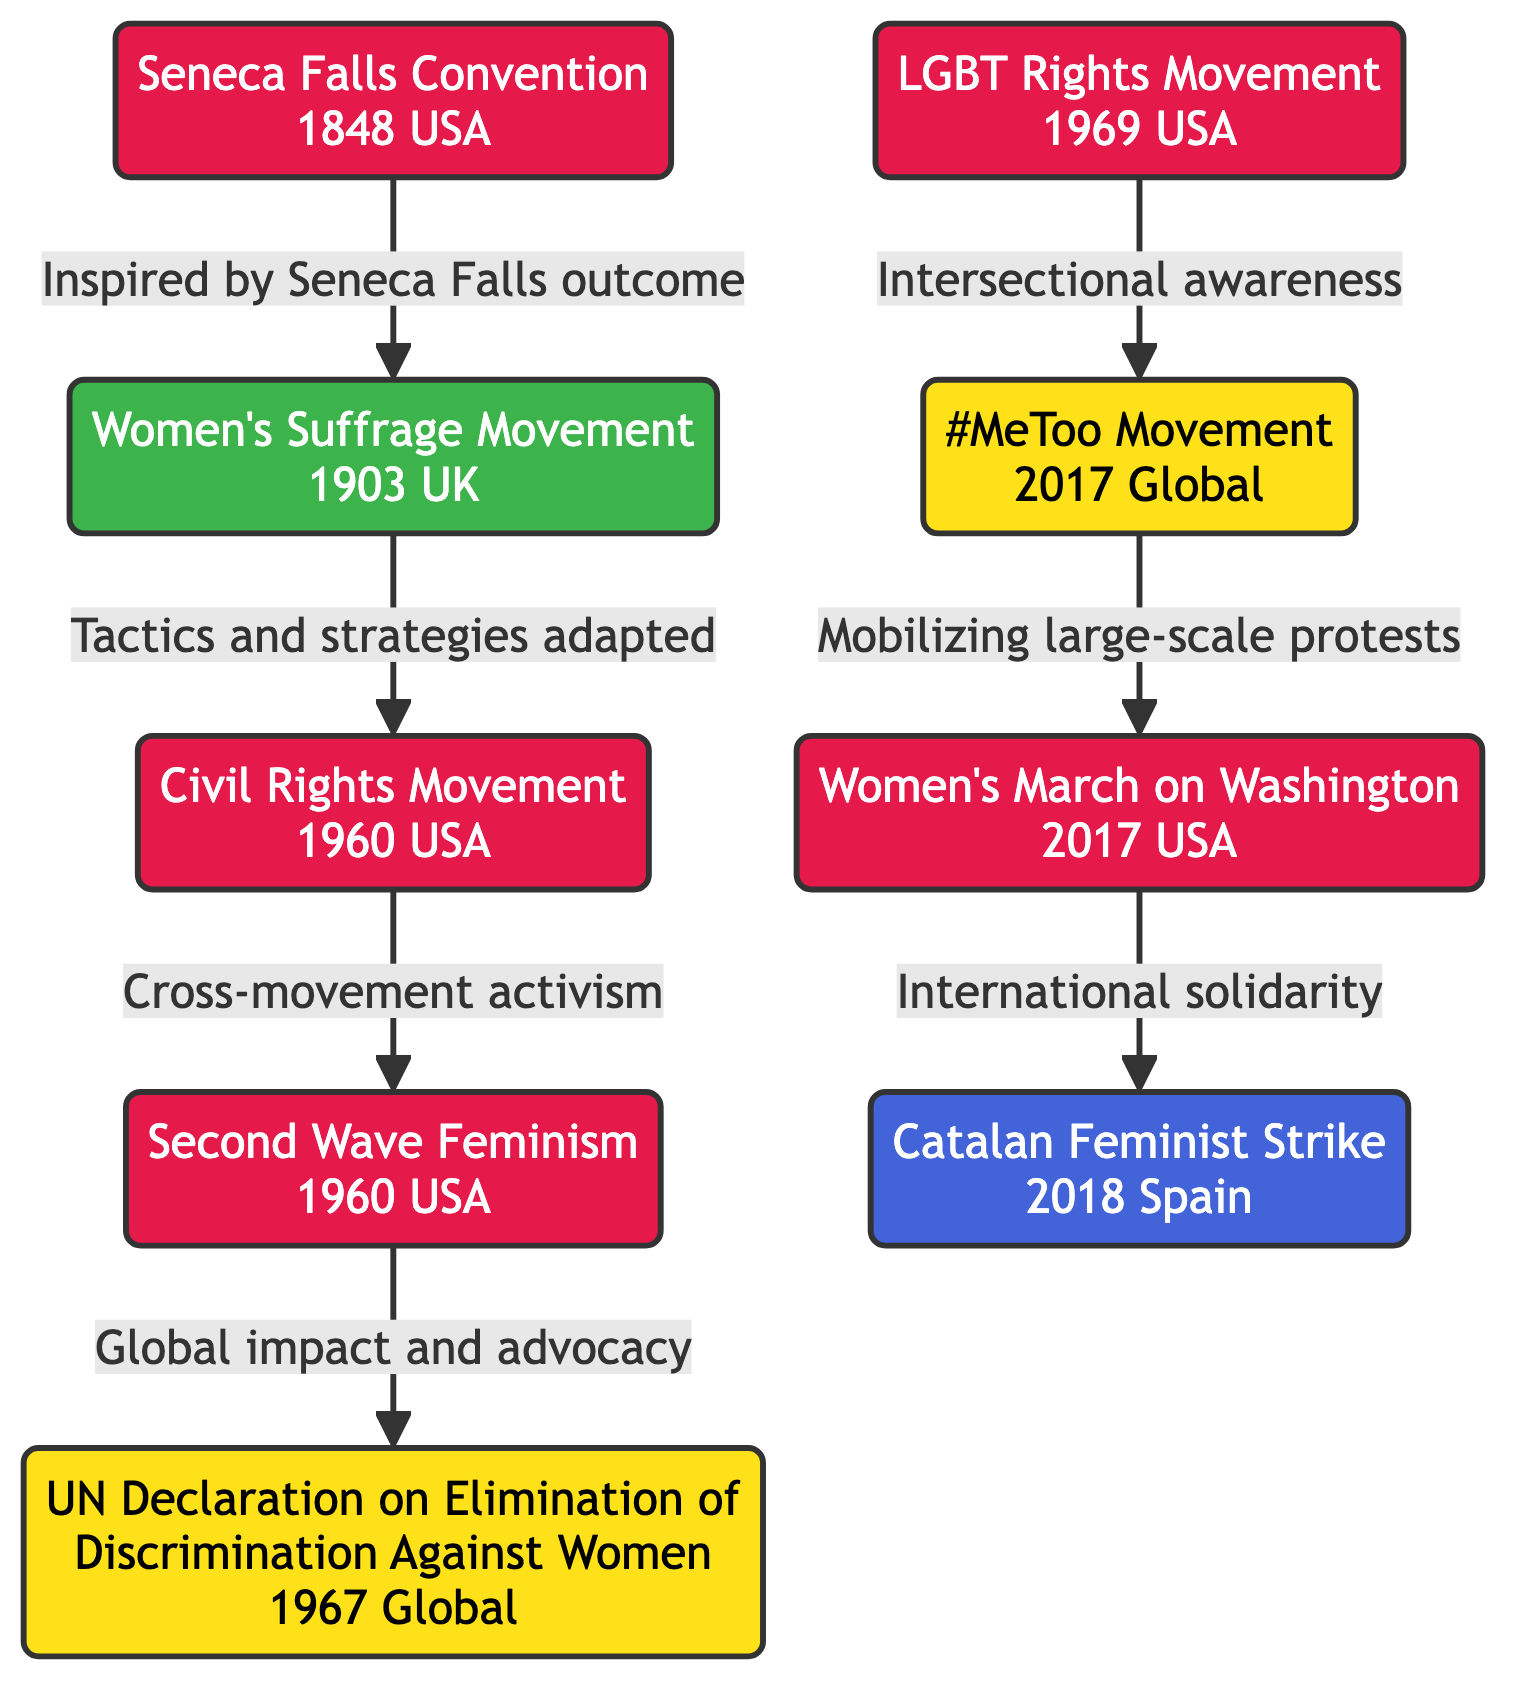What is the first movement listed in the diagram? The first movement in the diagram is from the node "Seneca Falls Convention" which is identified as occurring in 1848 in the USA. This information is clearly stated as the title of the first node.
Answer: Seneca Falls Convention How many nodes are present in the diagram? To determine the number of nodes, I counted each unique movement represented in the diagram. There are eight distinct movements listed as nodes.
Answer: 8 Which two movements are connected by the edge describing "Tactics and strategies adapted"? The edge indicating "Tactics and strategies adapted" connects the "Women's Suffrage Movement" node to the "Civil Rights Movement" node. This edge is labeled with its description and indicates the flow from one node to another.
Answer: Women's Suffrage Movement, Civil Rights Movement What year did the Women's March on Washington occur? By examining the node titled "Women's March on Washington," it is stated that this event occurred in the year 2017. The year is part of the node's description.
Answer: 2017 Which movement had a global impact and led to the UN Declaration? The node labeled "Second Wave Feminism" indicates that it had a global impact and is connected to the "UN Declaration on Elimination of Discrimination Against Women." The relationship is shown in the directed edge between these two nodes.
Answer: Second Wave Feminism Which two movements show an intersectional relationship? The edge labeled "Intersectional awareness" connects the "LGBT Rights Movement" and the "#MeToo Movement," indicating that these two movements share a relationship based on intersectionality. The presence of this edge and its description provides this information.
Answer: LGBT Rights Movement, #MeToo Movement How does the Women's March on Washington relate to the Catalan Feminist Strike? The edge labeled "International solidarity" shows that the "Women's March on Washington" directly connects to the "Catalan Feminist Strike," indicating a relationship of support and alignment between these two movements.
Answer: International solidarity What is the significance of the Seneca Falls Convention in this timeline? The "Seneca Falls Convention" marked the initiation of the women's rights movement in the USA in 1848, setting a precedent for subsequent movements. This significance is illustrated by how it inspired the "Women's Suffrage Movement" as indicated by the directed edge connecting these nodes.
Answer: Inspired later movements 